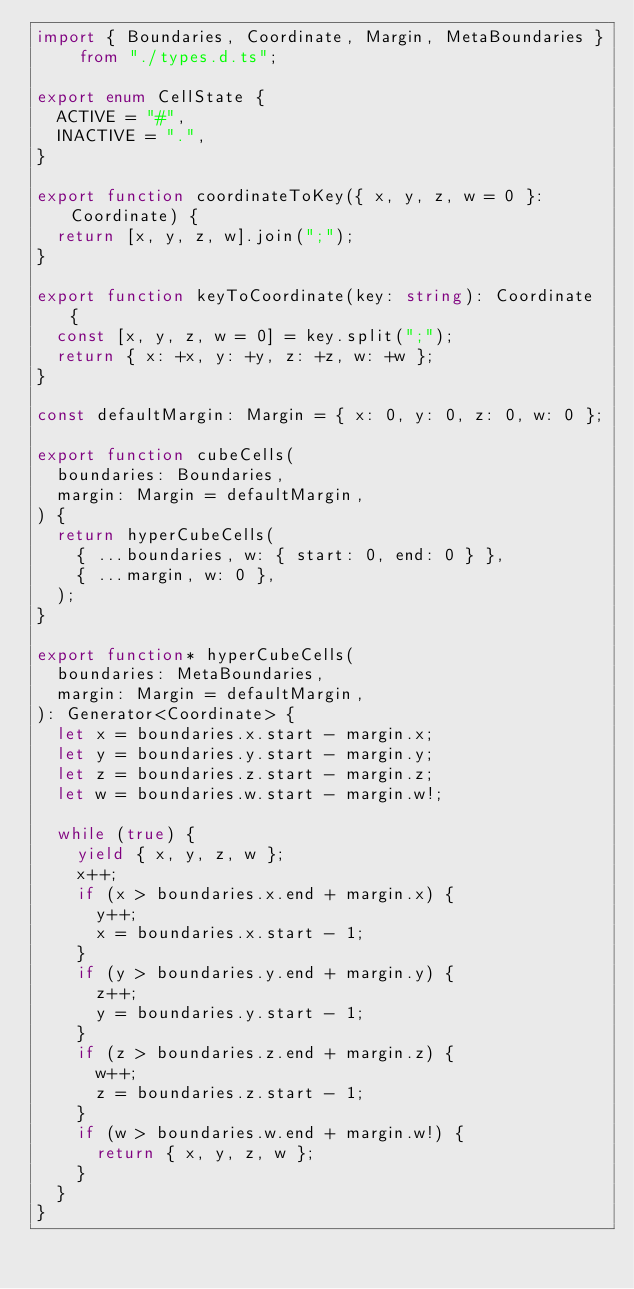<code> <loc_0><loc_0><loc_500><loc_500><_TypeScript_>import { Boundaries, Coordinate, Margin, MetaBoundaries } from "./types.d.ts";

export enum CellState {
  ACTIVE = "#",
  INACTIVE = ".",
}

export function coordinateToKey({ x, y, z, w = 0 }: Coordinate) {
  return [x, y, z, w].join(";");
}

export function keyToCoordinate(key: string): Coordinate {
  const [x, y, z, w = 0] = key.split(";");
  return { x: +x, y: +y, z: +z, w: +w };
}

const defaultMargin: Margin = { x: 0, y: 0, z: 0, w: 0 };

export function cubeCells(
  boundaries: Boundaries,
  margin: Margin = defaultMargin,
) {
  return hyperCubeCells(
    { ...boundaries, w: { start: 0, end: 0 } },
    { ...margin, w: 0 },
  );
}

export function* hyperCubeCells(
  boundaries: MetaBoundaries,
  margin: Margin = defaultMargin,
): Generator<Coordinate> {
  let x = boundaries.x.start - margin.x;
  let y = boundaries.y.start - margin.y;
  let z = boundaries.z.start - margin.z;
  let w = boundaries.w.start - margin.w!;

  while (true) {
    yield { x, y, z, w };
    x++;
    if (x > boundaries.x.end + margin.x) {
      y++;
      x = boundaries.x.start - 1;
    }
    if (y > boundaries.y.end + margin.y) {
      z++;
      y = boundaries.y.start - 1;
    }
    if (z > boundaries.z.end + margin.z) {
      w++;
      z = boundaries.z.start - 1;
    }
    if (w > boundaries.w.end + margin.w!) {
      return { x, y, z, w };
    }
  }
}
</code> 